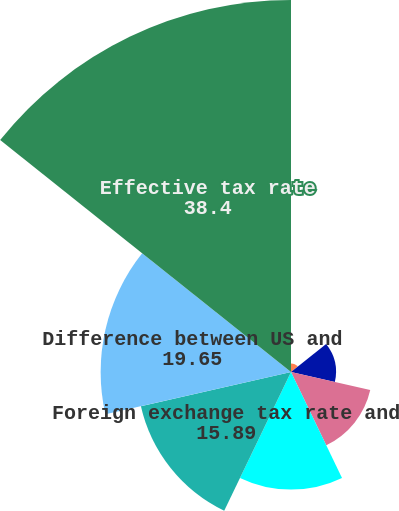Convert chart to OTSL. <chart><loc_0><loc_0><loc_500><loc_500><pie_chart><fcel>Earnings (losses) of equity<fcel>Permanent items<fcel>State and local income tax<fcel>Tax credits<fcel>Foreign exchange tax rate and<fcel>Difference between US and<fcel>Effective tax rate<nl><fcel>0.89%<fcel>4.64%<fcel>8.39%<fcel>12.14%<fcel>15.89%<fcel>19.65%<fcel>38.4%<nl></chart> 